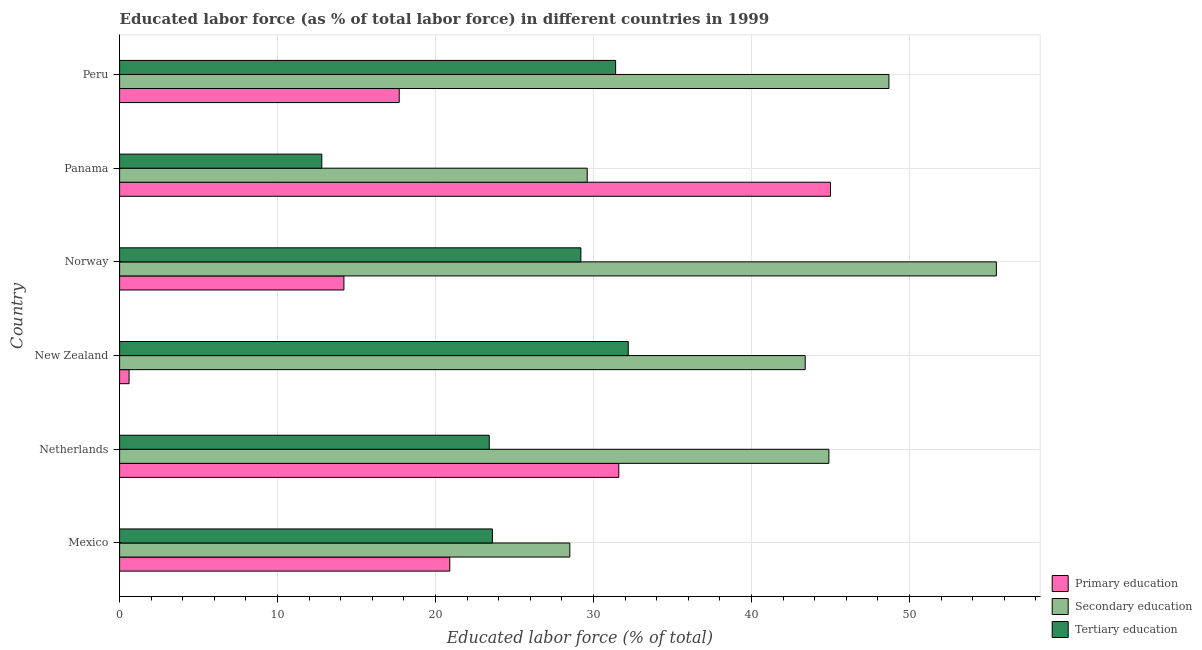Are the number of bars per tick equal to the number of legend labels?
Provide a short and direct response. Yes. Are the number of bars on each tick of the Y-axis equal?
Ensure brevity in your answer.  Yes. What is the label of the 6th group of bars from the top?
Offer a terse response. Mexico. In how many cases, is the number of bars for a given country not equal to the number of legend labels?
Your answer should be very brief. 0. What is the percentage of labor force who received tertiary education in New Zealand?
Offer a terse response. 32.2. Across all countries, what is the maximum percentage of labor force who received tertiary education?
Give a very brief answer. 32.2. In which country was the percentage of labor force who received primary education maximum?
Your response must be concise. Panama. In which country was the percentage of labor force who received tertiary education minimum?
Provide a succinct answer. Panama. What is the total percentage of labor force who received primary education in the graph?
Give a very brief answer. 130. What is the difference between the percentage of labor force who received primary education in Norway and that in Panama?
Provide a succinct answer. -30.8. What is the average percentage of labor force who received tertiary education per country?
Keep it short and to the point. 25.43. What is the difference between the percentage of labor force who received tertiary education and percentage of labor force who received primary education in Panama?
Ensure brevity in your answer.  -32.2. In how many countries, is the percentage of labor force who received primary education greater than 42 %?
Keep it short and to the point. 1. What is the ratio of the percentage of labor force who received tertiary education in Mexico to that in Peru?
Offer a very short reply. 0.75. Is the difference between the percentage of labor force who received secondary education in Netherlands and Peru greater than the difference between the percentage of labor force who received tertiary education in Netherlands and Peru?
Ensure brevity in your answer.  Yes. What is the difference between the highest and the lowest percentage of labor force who received primary education?
Keep it short and to the point. 44.4. In how many countries, is the percentage of labor force who received tertiary education greater than the average percentage of labor force who received tertiary education taken over all countries?
Provide a short and direct response. 3. Is the sum of the percentage of labor force who received tertiary education in Panama and Peru greater than the maximum percentage of labor force who received primary education across all countries?
Provide a succinct answer. No. What does the 3rd bar from the bottom in Panama represents?
Give a very brief answer. Tertiary education. Are all the bars in the graph horizontal?
Ensure brevity in your answer.  Yes. How many countries are there in the graph?
Offer a terse response. 6. Are the values on the major ticks of X-axis written in scientific E-notation?
Offer a very short reply. No. Where does the legend appear in the graph?
Ensure brevity in your answer.  Bottom right. How are the legend labels stacked?
Offer a terse response. Vertical. What is the title of the graph?
Your answer should be very brief. Educated labor force (as % of total labor force) in different countries in 1999. What is the label or title of the X-axis?
Provide a short and direct response. Educated labor force (% of total). What is the Educated labor force (% of total) of Primary education in Mexico?
Ensure brevity in your answer.  20.9. What is the Educated labor force (% of total) in Tertiary education in Mexico?
Your answer should be compact. 23.6. What is the Educated labor force (% of total) in Primary education in Netherlands?
Ensure brevity in your answer.  31.6. What is the Educated labor force (% of total) of Secondary education in Netherlands?
Provide a short and direct response. 44.9. What is the Educated labor force (% of total) in Tertiary education in Netherlands?
Offer a very short reply. 23.4. What is the Educated labor force (% of total) of Primary education in New Zealand?
Provide a short and direct response. 0.6. What is the Educated labor force (% of total) of Secondary education in New Zealand?
Provide a short and direct response. 43.4. What is the Educated labor force (% of total) in Tertiary education in New Zealand?
Keep it short and to the point. 32.2. What is the Educated labor force (% of total) of Primary education in Norway?
Provide a short and direct response. 14.2. What is the Educated labor force (% of total) in Secondary education in Norway?
Offer a terse response. 55.5. What is the Educated labor force (% of total) of Tertiary education in Norway?
Your answer should be compact. 29.2. What is the Educated labor force (% of total) in Primary education in Panama?
Make the answer very short. 45. What is the Educated labor force (% of total) in Secondary education in Panama?
Your response must be concise. 29.6. What is the Educated labor force (% of total) of Tertiary education in Panama?
Ensure brevity in your answer.  12.8. What is the Educated labor force (% of total) of Primary education in Peru?
Give a very brief answer. 17.7. What is the Educated labor force (% of total) of Secondary education in Peru?
Make the answer very short. 48.7. What is the Educated labor force (% of total) of Tertiary education in Peru?
Provide a succinct answer. 31.4. Across all countries, what is the maximum Educated labor force (% of total) in Primary education?
Give a very brief answer. 45. Across all countries, what is the maximum Educated labor force (% of total) of Secondary education?
Make the answer very short. 55.5. Across all countries, what is the maximum Educated labor force (% of total) in Tertiary education?
Keep it short and to the point. 32.2. Across all countries, what is the minimum Educated labor force (% of total) of Primary education?
Offer a terse response. 0.6. Across all countries, what is the minimum Educated labor force (% of total) in Secondary education?
Give a very brief answer. 28.5. Across all countries, what is the minimum Educated labor force (% of total) of Tertiary education?
Offer a terse response. 12.8. What is the total Educated labor force (% of total) in Primary education in the graph?
Your answer should be compact. 130. What is the total Educated labor force (% of total) in Secondary education in the graph?
Keep it short and to the point. 250.6. What is the total Educated labor force (% of total) in Tertiary education in the graph?
Your answer should be very brief. 152.6. What is the difference between the Educated labor force (% of total) of Primary education in Mexico and that in Netherlands?
Provide a succinct answer. -10.7. What is the difference between the Educated labor force (% of total) in Secondary education in Mexico and that in Netherlands?
Your answer should be very brief. -16.4. What is the difference between the Educated labor force (% of total) in Primary education in Mexico and that in New Zealand?
Offer a terse response. 20.3. What is the difference between the Educated labor force (% of total) in Secondary education in Mexico and that in New Zealand?
Provide a short and direct response. -14.9. What is the difference between the Educated labor force (% of total) in Tertiary education in Mexico and that in New Zealand?
Your response must be concise. -8.6. What is the difference between the Educated labor force (% of total) in Primary education in Mexico and that in Norway?
Provide a short and direct response. 6.7. What is the difference between the Educated labor force (% of total) in Secondary education in Mexico and that in Norway?
Provide a short and direct response. -27. What is the difference between the Educated labor force (% of total) in Tertiary education in Mexico and that in Norway?
Your answer should be very brief. -5.6. What is the difference between the Educated labor force (% of total) in Primary education in Mexico and that in Panama?
Provide a succinct answer. -24.1. What is the difference between the Educated labor force (% of total) in Tertiary education in Mexico and that in Panama?
Your answer should be compact. 10.8. What is the difference between the Educated labor force (% of total) of Primary education in Mexico and that in Peru?
Your response must be concise. 3.2. What is the difference between the Educated labor force (% of total) of Secondary education in Mexico and that in Peru?
Provide a short and direct response. -20.2. What is the difference between the Educated labor force (% of total) of Primary education in Netherlands and that in New Zealand?
Give a very brief answer. 31. What is the difference between the Educated labor force (% of total) in Tertiary education in Netherlands and that in New Zealand?
Offer a very short reply. -8.8. What is the difference between the Educated labor force (% of total) in Primary education in Netherlands and that in Norway?
Your response must be concise. 17.4. What is the difference between the Educated labor force (% of total) of Primary education in Netherlands and that in Panama?
Offer a terse response. -13.4. What is the difference between the Educated labor force (% of total) of Secondary education in Netherlands and that in Panama?
Your answer should be compact. 15.3. What is the difference between the Educated labor force (% of total) of Tertiary education in Netherlands and that in Panama?
Keep it short and to the point. 10.6. What is the difference between the Educated labor force (% of total) in Primary education in New Zealand and that in Norway?
Offer a very short reply. -13.6. What is the difference between the Educated labor force (% of total) of Primary education in New Zealand and that in Panama?
Provide a short and direct response. -44.4. What is the difference between the Educated labor force (% of total) of Secondary education in New Zealand and that in Panama?
Keep it short and to the point. 13.8. What is the difference between the Educated labor force (% of total) of Tertiary education in New Zealand and that in Panama?
Ensure brevity in your answer.  19.4. What is the difference between the Educated labor force (% of total) of Primary education in New Zealand and that in Peru?
Offer a terse response. -17.1. What is the difference between the Educated labor force (% of total) in Primary education in Norway and that in Panama?
Offer a terse response. -30.8. What is the difference between the Educated labor force (% of total) of Secondary education in Norway and that in Panama?
Provide a succinct answer. 25.9. What is the difference between the Educated labor force (% of total) in Tertiary education in Norway and that in Panama?
Your answer should be compact. 16.4. What is the difference between the Educated labor force (% of total) in Primary education in Norway and that in Peru?
Make the answer very short. -3.5. What is the difference between the Educated labor force (% of total) of Secondary education in Norway and that in Peru?
Offer a terse response. 6.8. What is the difference between the Educated labor force (% of total) of Primary education in Panama and that in Peru?
Provide a short and direct response. 27.3. What is the difference between the Educated labor force (% of total) in Secondary education in Panama and that in Peru?
Your response must be concise. -19.1. What is the difference between the Educated labor force (% of total) of Tertiary education in Panama and that in Peru?
Make the answer very short. -18.6. What is the difference between the Educated labor force (% of total) in Primary education in Mexico and the Educated labor force (% of total) in Secondary education in Netherlands?
Offer a terse response. -24. What is the difference between the Educated labor force (% of total) of Primary education in Mexico and the Educated labor force (% of total) of Tertiary education in Netherlands?
Provide a short and direct response. -2.5. What is the difference between the Educated labor force (% of total) of Primary education in Mexico and the Educated labor force (% of total) of Secondary education in New Zealand?
Provide a short and direct response. -22.5. What is the difference between the Educated labor force (% of total) of Primary education in Mexico and the Educated labor force (% of total) of Secondary education in Norway?
Your answer should be compact. -34.6. What is the difference between the Educated labor force (% of total) of Primary education in Mexico and the Educated labor force (% of total) of Tertiary education in Norway?
Give a very brief answer. -8.3. What is the difference between the Educated labor force (% of total) of Secondary education in Mexico and the Educated labor force (% of total) of Tertiary education in Norway?
Offer a very short reply. -0.7. What is the difference between the Educated labor force (% of total) of Primary education in Mexico and the Educated labor force (% of total) of Secondary education in Panama?
Keep it short and to the point. -8.7. What is the difference between the Educated labor force (% of total) of Secondary education in Mexico and the Educated labor force (% of total) of Tertiary education in Panama?
Your answer should be very brief. 15.7. What is the difference between the Educated labor force (% of total) in Primary education in Mexico and the Educated labor force (% of total) in Secondary education in Peru?
Your answer should be compact. -27.8. What is the difference between the Educated labor force (% of total) of Secondary education in Mexico and the Educated labor force (% of total) of Tertiary education in Peru?
Offer a terse response. -2.9. What is the difference between the Educated labor force (% of total) in Primary education in Netherlands and the Educated labor force (% of total) in Secondary education in New Zealand?
Make the answer very short. -11.8. What is the difference between the Educated labor force (% of total) in Primary education in Netherlands and the Educated labor force (% of total) in Secondary education in Norway?
Provide a succinct answer. -23.9. What is the difference between the Educated labor force (% of total) of Primary education in Netherlands and the Educated labor force (% of total) of Tertiary education in Norway?
Make the answer very short. 2.4. What is the difference between the Educated labor force (% of total) of Secondary education in Netherlands and the Educated labor force (% of total) of Tertiary education in Norway?
Keep it short and to the point. 15.7. What is the difference between the Educated labor force (% of total) in Secondary education in Netherlands and the Educated labor force (% of total) in Tertiary education in Panama?
Provide a succinct answer. 32.1. What is the difference between the Educated labor force (% of total) in Primary education in Netherlands and the Educated labor force (% of total) in Secondary education in Peru?
Offer a terse response. -17.1. What is the difference between the Educated labor force (% of total) of Secondary education in Netherlands and the Educated labor force (% of total) of Tertiary education in Peru?
Offer a very short reply. 13.5. What is the difference between the Educated labor force (% of total) in Primary education in New Zealand and the Educated labor force (% of total) in Secondary education in Norway?
Provide a short and direct response. -54.9. What is the difference between the Educated labor force (% of total) in Primary education in New Zealand and the Educated labor force (% of total) in Tertiary education in Norway?
Your answer should be very brief. -28.6. What is the difference between the Educated labor force (% of total) of Primary education in New Zealand and the Educated labor force (% of total) of Secondary education in Panama?
Make the answer very short. -29. What is the difference between the Educated labor force (% of total) of Secondary education in New Zealand and the Educated labor force (% of total) of Tertiary education in Panama?
Provide a short and direct response. 30.6. What is the difference between the Educated labor force (% of total) in Primary education in New Zealand and the Educated labor force (% of total) in Secondary education in Peru?
Give a very brief answer. -48.1. What is the difference between the Educated labor force (% of total) in Primary education in New Zealand and the Educated labor force (% of total) in Tertiary education in Peru?
Your response must be concise. -30.8. What is the difference between the Educated labor force (% of total) of Secondary education in New Zealand and the Educated labor force (% of total) of Tertiary education in Peru?
Offer a terse response. 12. What is the difference between the Educated labor force (% of total) of Primary education in Norway and the Educated labor force (% of total) of Secondary education in Panama?
Your answer should be compact. -15.4. What is the difference between the Educated labor force (% of total) in Primary education in Norway and the Educated labor force (% of total) in Tertiary education in Panama?
Your answer should be compact. 1.4. What is the difference between the Educated labor force (% of total) of Secondary education in Norway and the Educated labor force (% of total) of Tertiary education in Panama?
Offer a very short reply. 42.7. What is the difference between the Educated labor force (% of total) in Primary education in Norway and the Educated labor force (% of total) in Secondary education in Peru?
Your response must be concise. -34.5. What is the difference between the Educated labor force (% of total) in Primary education in Norway and the Educated labor force (% of total) in Tertiary education in Peru?
Your response must be concise. -17.2. What is the difference between the Educated labor force (% of total) in Secondary education in Norway and the Educated labor force (% of total) in Tertiary education in Peru?
Keep it short and to the point. 24.1. What is the average Educated labor force (% of total) of Primary education per country?
Your answer should be very brief. 21.67. What is the average Educated labor force (% of total) of Secondary education per country?
Provide a short and direct response. 41.77. What is the average Educated labor force (% of total) in Tertiary education per country?
Keep it short and to the point. 25.43. What is the difference between the Educated labor force (% of total) of Primary education and Educated labor force (% of total) of Tertiary education in Mexico?
Provide a succinct answer. -2.7. What is the difference between the Educated labor force (% of total) in Primary education and Educated labor force (% of total) in Secondary education in Netherlands?
Offer a very short reply. -13.3. What is the difference between the Educated labor force (% of total) of Secondary education and Educated labor force (% of total) of Tertiary education in Netherlands?
Provide a succinct answer. 21.5. What is the difference between the Educated labor force (% of total) in Primary education and Educated labor force (% of total) in Secondary education in New Zealand?
Keep it short and to the point. -42.8. What is the difference between the Educated labor force (% of total) in Primary education and Educated labor force (% of total) in Tertiary education in New Zealand?
Ensure brevity in your answer.  -31.6. What is the difference between the Educated labor force (% of total) in Secondary education and Educated labor force (% of total) in Tertiary education in New Zealand?
Keep it short and to the point. 11.2. What is the difference between the Educated labor force (% of total) of Primary education and Educated labor force (% of total) of Secondary education in Norway?
Keep it short and to the point. -41.3. What is the difference between the Educated labor force (% of total) of Secondary education and Educated labor force (% of total) of Tertiary education in Norway?
Give a very brief answer. 26.3. What is the difference between the Educated labor force (% of total) in Primary education and Educated labor force (% of total) in Tertiary education in Panama?
Make the answer very short. 32.2. What is the difference between the Educated labor force (% of total) in Primary education and Educated labor force (% of total) in Secondary education in Peru?
Provide a short and direct response. -31. What is the difference between the Educated labor force (% of total) in Primary education and Educated labor force (% of total) in Tertiary education in Peru?
Offer a very short reply. -13.7. What is the difference between the Educated labor force (% of total) in Secondary education and Educated labor force (% of total) in Tertiary education in Peru?
Your answer should be compact. 17.3. What is the ratio of the Educated labor force (% of total) of Primary education in Mexico to that in Netherlands?
Give a very brief answer. 0.66. What is the ratio of the Educated labor force (% of total) of Secondary education in Mexico to that in Netherlands?
Keep it short and to the point. 0.63. What is the ratio of the Educated labor force (% of total) of Tertiary education in Mexico to that in Netherlands?
Provide a short and direct response. 1.01. What is the ratio of the Educated labor force (% of total) of Primary education in Mexico to that in New Zealand?
Provide a short and direct response. 34.83. What is the ratio of the Educated labor force (% of total) in Secondary education in Mexico to that in New Zealand?
Your response must be concise. 0.66. What is the ratio of the Educated labor force (% of total) in Tertiary education in Mexico to that in New Zealand?
Your response must be concise. 0.73. What is the ratio of the Educated labor force (% of total) in Primary education in Mexico to that in Norway?
Provide a succinct answer. 1.47. What is the ratio of the Educated labor force (% of total) of Secondary education in Mexico to that in Norway?
Keep it short and to the point. 0.51. What is the ratio of the Educated labor force (% of total) in Tertiary education in Mexico to that in Norway?
Ensure brevity in your answer.  0.81. What is the ratio of the Educated labor force (% of total) of Primary education in Mexico to that in Panama?
Your response must be concise. 0.46. What is the ratio of the Educated labor force (% of total) of Secondary education in Mexico to that in Panama?
Your answer should be compact. 0.96. What is the ratio of the Educated labor force (% of total) of Tertiary education in Mexico to that in Panama?
Provide a short and direct response. 1.84. What is the ratio of the Educated labor force (% of total) of Primary education in Mexico to that in Peru?
Keep it short and to the point. 1.18. What is the ratio of the Educated labor force (% of total) in Secondary education in Mexico to that in Peru?
Offer a very short reply. 0.59. What is the ratio of the Educated labor force (% of total) in Tertiary education in Mexico to that in Peru?
Your response must be concise. 0.75. What is the ratio of the Educated labor force (% of total) in Primary education in Netherlands to that in New Zealand?
Give a very brief answer. 52.67. What is the ratio of the Educated labor force (% of total) of Secondary education in Netherlands to that in New Zealand?
Offer a very short reply. 1.03. What is the ratio of the Educated labor force (% of total) of Tertiary education in Netherlands to that in New Zealand?
Offer a very short reply. 0.73. What is the ratio of the Educated labor force (% of total) of Primary education in Netherlands to that in Norway?
Your answer should be very brief. 2.23. What is the ratio of the Educated labor force (% of total) of Secondary education in Netherlands to that in Norway?
Your answer should be very brief. 0.81. What is the ratio of the Educated labor force (% of total) in Tertiary education in Netherlands to that in Norway?
Offer a very short reply. 0.8. What is the ratio of the Educated labor force (% of total) of Primary education in Netherlands to that in Panama?
Ensure brevity in your answer.  0.7. What is the ratio of the Educated labor force (% of total) in Secondary education in Netherlands to that in Panama?
Make the answer very short. 1.52. What is the ratio of the Educated labor force (% of total) of Tertiary education in Netherlands to that in Panama?
Offer a terse response. 1.83. What is the ratio of the Educated labor force (% of total) of Primary education in Netherlands to that in Peru?
Offer a very short reply. 1.79. What is the ratio of the Educated labor force (% of total) in Secondary education in Netherlands to that in Peru?
Your answer should be very brief. 0.92. What is the ratio of the Educated labor force (% of total) in Tertiary education in Netherlands to that in Peru?
Offer a terse response. 0.75. What is the ratio of the Educated labor force (% of total) in Primary education in New Zealand to that in Norway?
Keep it short and to the point. 0.04. What is the ratio of the Educated labor force (% of total) in Secondary education in New Zealand to that in Norway?
Provide a succinct answer. 0.78. What is the ratio of the Educated labor force (% of total) of Tertiary education in New Zealand to that in Norway?
Provide a short and direct response. 1.1. What is the ratio of the Educated labor force (% of total) in Primary education in New Zealand to that in Panama?
Give a very brief answer. 0.01. What is the ratio of the Educated labor force (% of total) in Secondary education in New Zealand to that in Panama?
Keep it short and to the point. 1.47. What is the ratio of the Educated labor force (% of total) in Tertiary education in New Zealand to that in Panama?
Give a very brief answer. 2.52. What is the ratio of the Educated labor force (% of total) of Primary education in New Zealand to that in Peru?
Your answer should be very brief. 0.03. What is the ratio of the Educated labor force (% of total) of Secondary education in New Zealand to that in Peru?
Your answer should be compact. 0.89. What is the ratio of the Educated labor force (% of total) in Tertiary education in New Zealand to that in Peru?
Give a very brief answer. 1.03. What is the ratio of the Educated labor force (% of total) of Primary education in Norway to that in Panama?
Provide a succinct answer. 0.32. What is the ratio of the Educated labor force (% of total) in Secondary education in Norway to that in Panama?
Make the answer very short. 1.88. What is the ratio of the Educated labor force (% of total) in Tertiary education in Norway to that in Panama?
Ensure brevity in your answer.  2.28. What is the ratio of the Educated labor force (% of total) in Primary education in Norway to that in Peru?
Your answer should be very brief. 0.8. What is the ratio of the Educated labor force (% of total) in Secondary education in Norway to that in Peru?
Keep it short and to the point. 1.14. What is the ratio of the Educated labor force (% of total) in Tertiary education in Norway to that in Peru?
Offer a very short reply. 0.93. What is the ratio of the Educated labor force (% of total) of Primary education in Panama to that in Peru?
Offer a very short reply. 2.54. What is the ratio of the Educated labor force (% of total) of Secondary education in Panama to that in Peru?
Keep it short and to the point. 0.61. What is the ratio of the Educated labor force (% of total) in Tertiary education in Panama to that in Peru?
Your answer should be compact. 0.41. What is the difference between the highest and the lowest Educated labor force (% of total) of Primary education?
Make the answer very short. 44.4. 